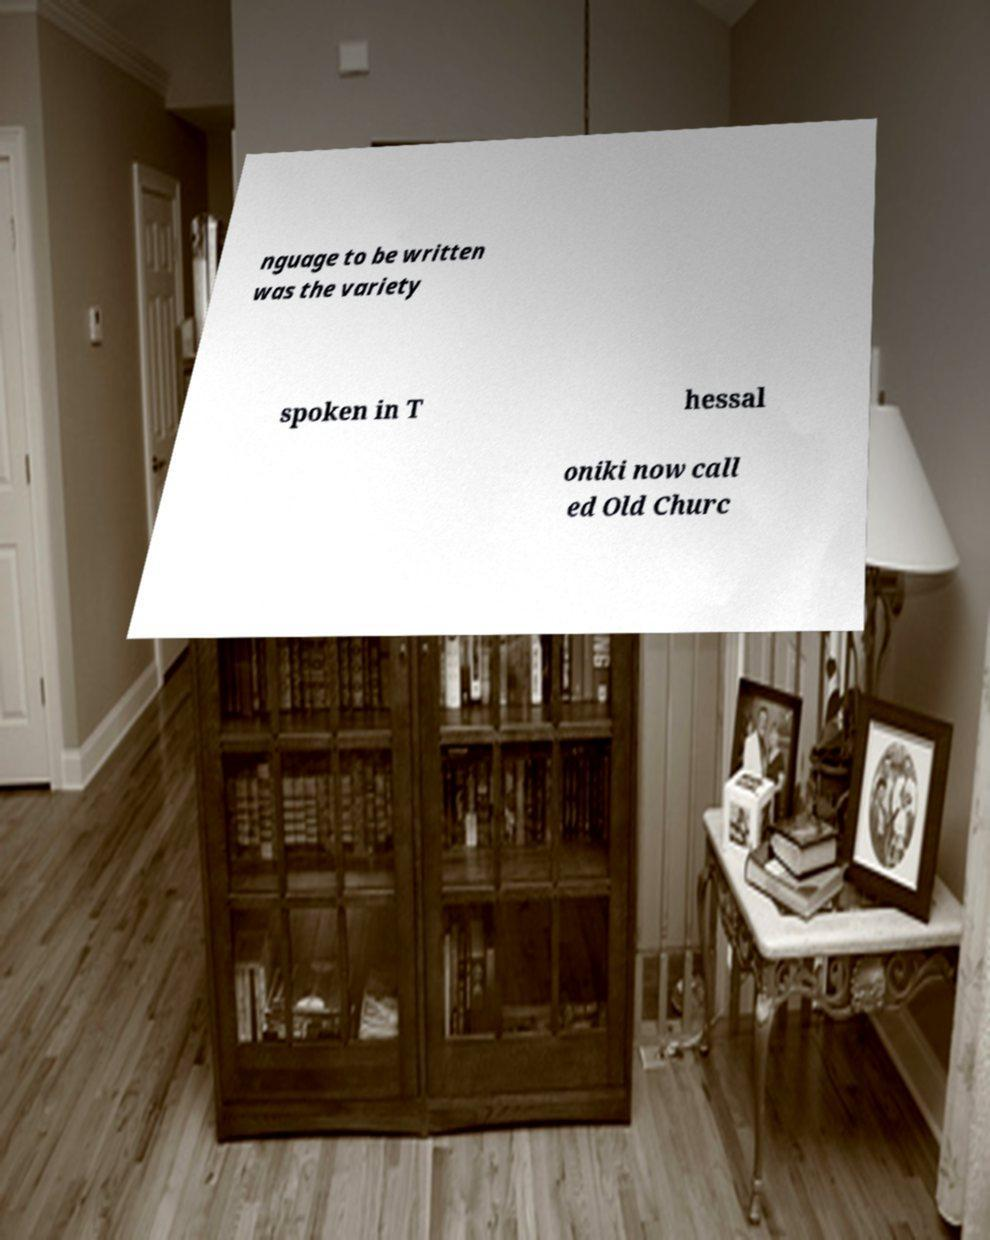Can you accurately transcribe the text from the provided image for me? nguage to be written was the variety spoken in T hessal oniki now call ed Old Churc 